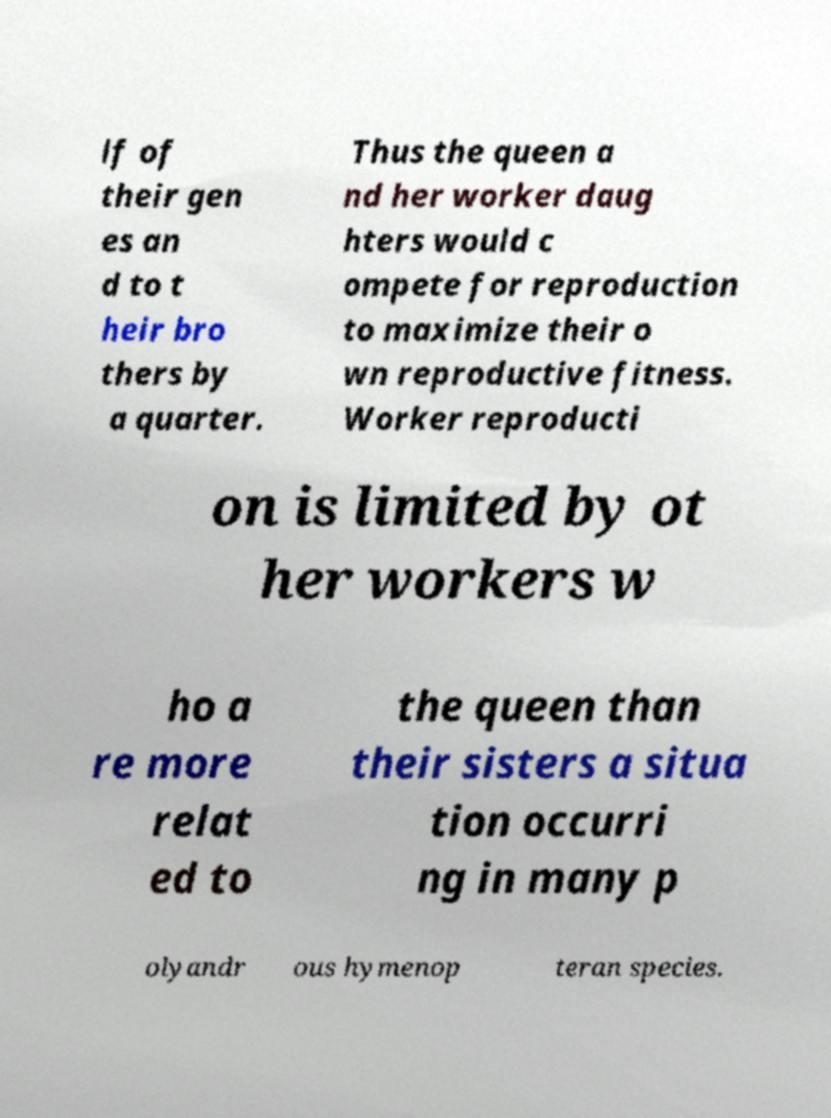There's text embedded in this image that I need extracted. Can you transcribe it verbatim? lf of their gen es an d to t heir bro thers by a quarter. Thus the queen a nd her worker daug hters would c ompete for reproduction to maximize their o wn reproductive fitness. Worker reproducti on is limited by ot her workers w ho a re more relat ed to the queen than their sisters a situa tion occurri ng in many p olyandr ous hymenop teran species. 